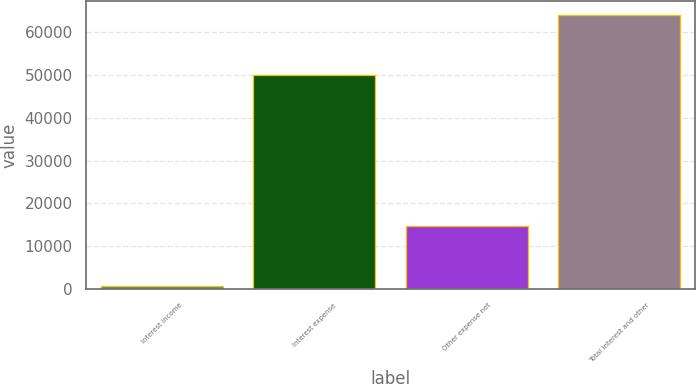Convert chart to OTSL. <chart><loc_0><loc_0><loc_500><loc_500><bar_chart><fcel>Interest income<fcel>Interest expense<fcel>Other expense net<fcel>Total interest and other<nl><fcel>650<fcel>49924<fcel>14836<fcel>64110<nl></chart> 